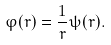Convert formula to latex. <formula><loc_0><loc_0><loc_500><loc_500>\varphi ( r ) = \frac { 1 } { r } \psi ( r ) .</formula> 